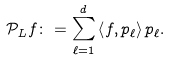<formula> <loc_0><loc_0><loc_500><loc_500>\mathcal { P } _ { L } f \colon = \sum _ { \ell = 1 } ^ { d } \left < f , p _ { \ell } \right > p _ { \ell } .</formula> 